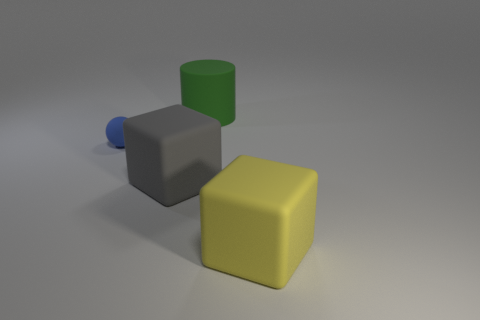Are there any other things that are the same size as the rubber sphere?
Your answer should be very brief. No. Is there anything else that has the same shape as the blue object?
Your response must be concise. No. What number of cyan cubes are the same material as the blue sphere?
Give a very brief answer. 0. What is the shape of the big thing that is behind the large yellow rubber cube and in front of the green object?
Your response must be concise. Cube. Does the big cube that is to the right of the gray object have the same material as the green cylinder?
Provide a succinct answer. Yes. Are there any other things that are made of the same material as the big yellow thing?
Offer a very short reply. Yes. What color is the block that is the same size as the yellow matte thing?
Give a very brief answer. Gray. Is there another rubber sphere of the same color as the matte ball?
Give a very brief answer. No. What is the size of the gray object that is the same material as the green thing?
Make the answer very short. Large. What number of other objects are the same size as the blue sphere?
Provide a short and direct response. 0. 